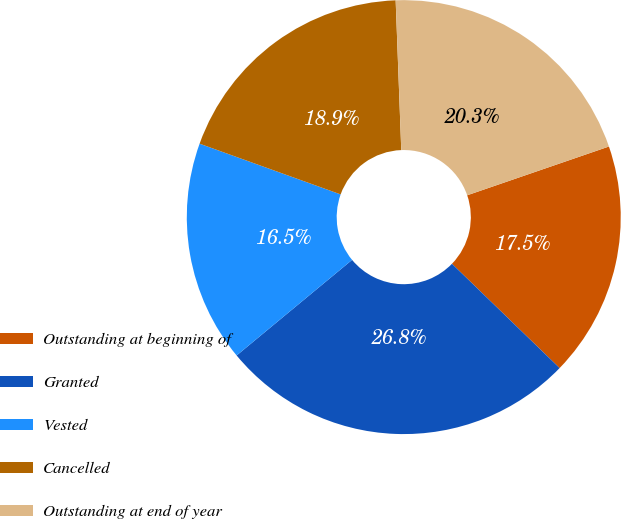Convert chart to OTSL. <chart><loc_0><loc_0><loc_500><loc_500><pie_chart><fcel>Outstanding at beginning of<fcel>Granted<fcel>Vested<fcel>Cancelled<fcel>Outstanding at end of year<nl><fcel>17.52%<fcel>26.75%<fcel>16.5%<fcel>18.91%<fcel>20.32%<nl></chart> 